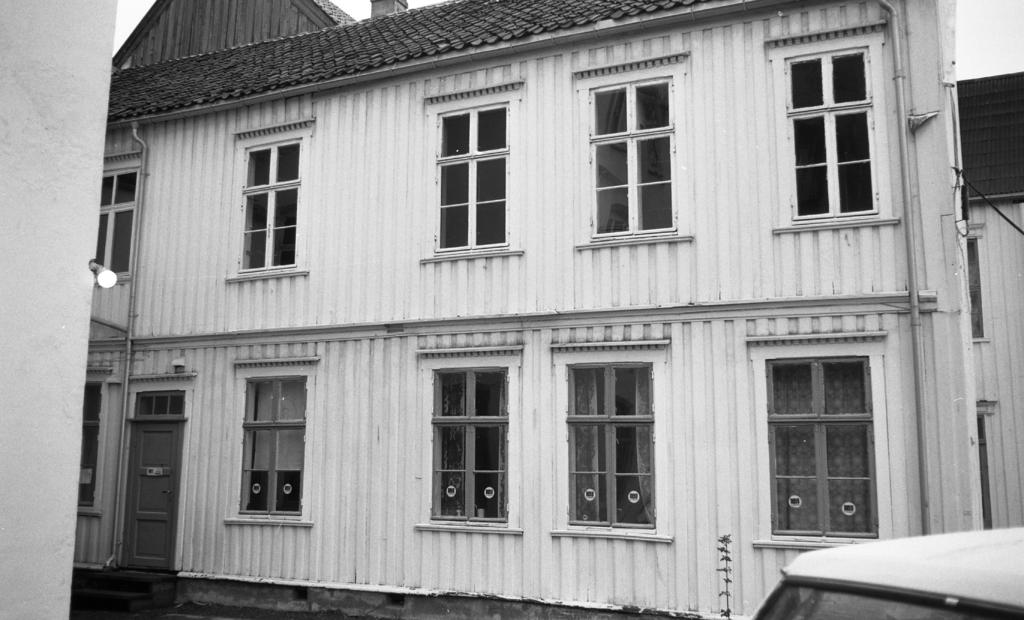What is the color scheme of the image? The image is black and white. What can be seen in the image besides the house? There is a vehicle in the image. What type of windows does the house have? The house has glass windows. How can the house be entered? The house has a door. What is the source of light in the image? There is light visible in the image. What is visible in the background of the image? The sky is visible in the background of the image. How many slaves are visible in the image? There are no slaves present in the image. What type of land can be seen in the image? The image does not depict any land; it is a black and white image of a house and a vehicle. 